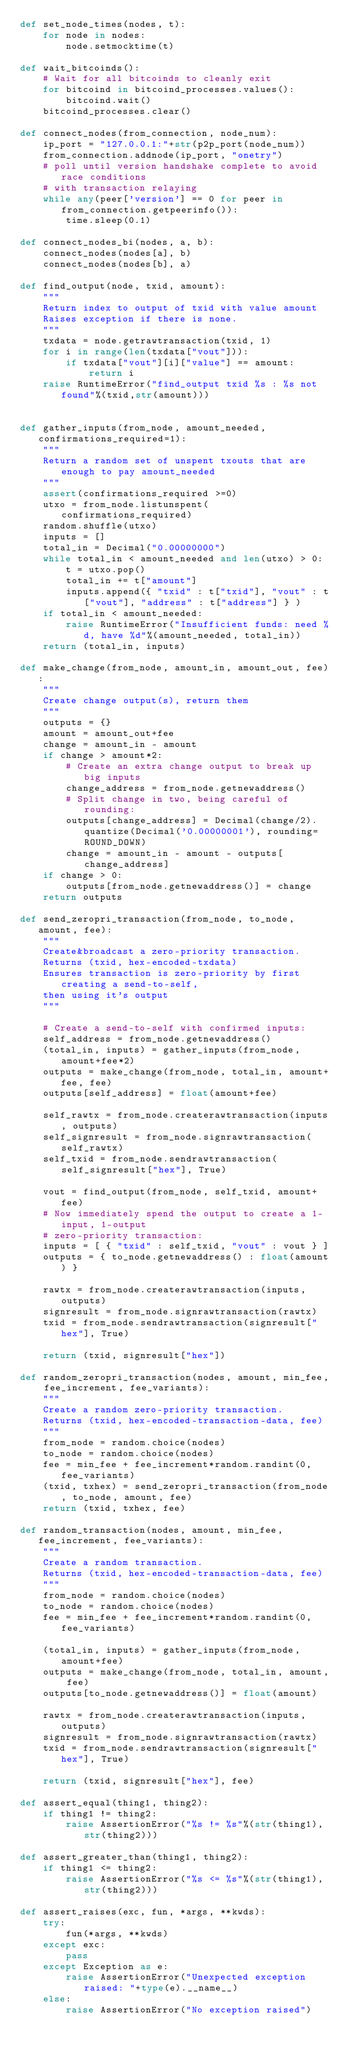<code> <loc_0><loc_0><loc_500><loc_500><_Python_>def set_node_times(nodes, t):
    for node in nodes:
        node.setmocktime(t)

def wait_bitcoinds():
    # Wait for all bitcoinds to cleanly exit
    for bitcoind in bitcoind_processes.values():
        bitcoind.wait()
    bitcoind_processes.clear()

def connect_nodes(from_connection, node_num):
    ip_port = "127.0.0.1:"+str(p2p_port(node_num))
    from_connection.addnode(ip_port, "onetry")
    # poll until version handshake complete to avoid race conditions
    # with transaction relaying
    while any(peer['version'] == 0 for peer in from_connection.getpeerinfo()):
        time.sleep(0.1)

def connect_nodes_bi(nodes, a, b):
    connect_nodes(nodes[a], b)
    connect_nodes(nodes[b], a)

def find_output(node, txid, amount):
    """
    Return index to output of txid with value amount
    Raises exception if there is none.
    """
    txdata = node.getrawtransaction(txid, 1)
    for i in range(len(txdata["vout"])):
        if txdata["vout"][i]["value"] == amount:
            return i
    raise RuntimeError("find_output txid %s : %s not found"%(txid,str(amount)))


def gather_inputs(from_node, amount_needed, confirmations_required=1):
    """
    Return a random set of unspent txouts that are enough to pay amount_needed
    """
    assert(confirmations_required >=0)
    utxo = from_node.listunspent(confirmations_required)
    random.shuffle(utxo)
    inputs = []
    total_in = Decimal("0.00000000")
    while total_in < amount_needed and len(utxo) > 0:
        t = utxo.pop()
        total_in += t["amount"]
        inputs.append({ "txid" : t["txid"], "vout" : t["vout"], "address" : t["address"] } )
    if total_in < amount_needed:
        raise RuntimeError("Insufficient funds: need %d, have %d"%(amount_needed, total_in))
    return (total_in, inputs)

def make_change(from_node, amount_in, amount_out, fee):
    """
    Create change output(s), return them
    """
    outputs = {}
    amount = amount_out+fee
    change = amount_in - amount
    if change > amount*2:
        # Create an extra change output to break up big inputs
        change_address = from_node.getnewaddress()
        # Split change in two, being careful of rounding:
        outputs[change_address] = Decimal(change/2).quantize(Decimal('0.00000001'), rounding=ROUND_DOWN)
        change = amount_in - amount - outputs[change_address]
    if change > 0:
        outputs[from_node.getnewaddress()] = change
    return outputs

def send_zeropri_transaction(from_node, to_node, amount, fee):
    """
    Create&broadcast a zero-priority transaction.
    Returns (txid, hex-encoded-txdata)
    Ensures transaction is zero-priority by first creating a send-to-self,
    then using it's output
    """

    # Create a send-to-self with confirmed inputs:
    self_address = from_node.getnewaddress()
    (total_in, inputs) = gather_inputs(from_node, amount+fee*2)
    outputs = make_change(from_node, total_in, amount+fee, fee)
    outputs[self_address] = float(amount+fee)

    self_rawtx = from_node.createrawtransaction(inputs, outputs)
    self_signresult = from_node.signrawtransaction(self_rawtx)
    self_txid = from_node.sendrawtransaction(self_signresult["hex"], True)

    vout = find_output(from_node, self_txid, amount+fee)
    # Now immediately spend the output to create a 1-input, 1-output
    # zero-priority transaction:
    inputs = [ { "txid" : self_txid, "vout" : vout } ]
    outputs = { to_node.getnewaddress() : float(amount) }

    rawtx = from_node.createrawtransaction(inputs, outputs)
    signresult = from_node.signrawtransaction(rawtx)
    txid = from_node.sendrawtransaction(signresult["hex"], True)

    return (txid, signresult["hex"])

def random_zeropri_transaction(nodes, amount, min_fee, fee_increment, fee_variants):
    """
    Create a random zero-priority transaction.
    Returns (txid, hex-encoded-transaction-data, fee)
    """
    from_node = random.choice(nodes)
    to_node = random.choice(nodes)
    fee = min_fee + fee_increment*random.randint(0,fee_variants)
    (txid, txhex) = send_zeropri_transaction(from_node, to_node, amount, fee)
    return (txid, txhex, fee)

def random_transaction(nodes, amount, min_fee, fee_increment, fee_variants):
    """
    Create a random transaction.
    Returns (txid, hex-encoded-transaction-data, fee)
    """
    from_node = random.choice(nodes)
    to_node = random.choice(nodes)
    fee = min_fee + fee_increment*random.randint(0,fee_variants)

    (total_in, inputs) = gather_inputs(from_node, amount+fee)
    outputs = make_change(from_node, total_in, amount, fee)
    outputs[to_node.getnewaddress()] = float(amount)

    rawtx = from_node.createrawtransaction(inputs, outputs)
    signresult = from_node.signrawtransaction(rawtx)
    txid = from_node.sendrawtransaction(signresult["hex"], True)

    return (txid, signresult["hex"], fee)

def assert_equal(thing1, thing2):
    if thing1 != thing2:
        raise AssertionError("%s != %s"%(str(thing1),str(thing2)))

def assert_greater_than(thing1, thing2):
    if thing1 <= thing2:
        raise AssertionError("%s <= %s"%(str(thing1),str(thing2)))

def assert_raises(exc, fun, *args, **kwds):
    try:
        fun(*args, **kwds)
    except exc:
        pass
    except Exception as e:
        raise AssertionError("Unexpected exception raised: "+type(e).__name__)
    else:
        raise AssertionError("No exception raised")
</code> 